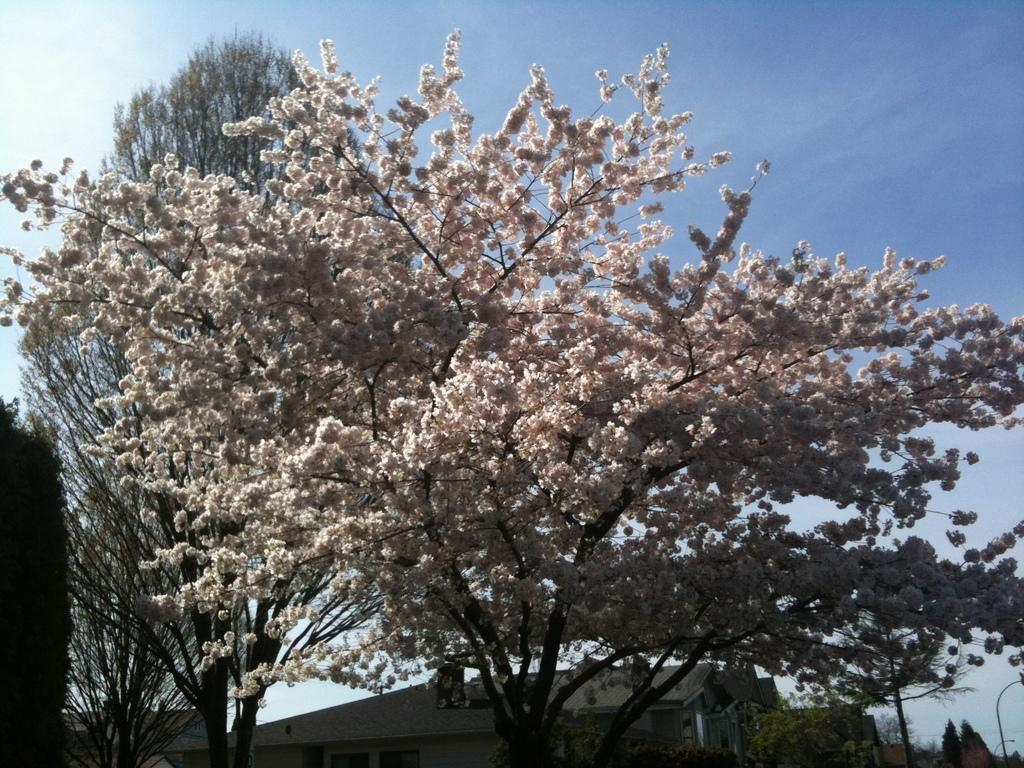What is the main subject in the middle of the image? There is a flower plant in the middle of the image. What can be seen in the background of the image? There are buildings in the background of the image. What is visible at the top of the image? The sky is visible at the top of the image. What type of vegetation is present on the tree? There are flowers on the tree. What type of iron is being used to hold the bag in the image? There is no iron or bag present in the image. 